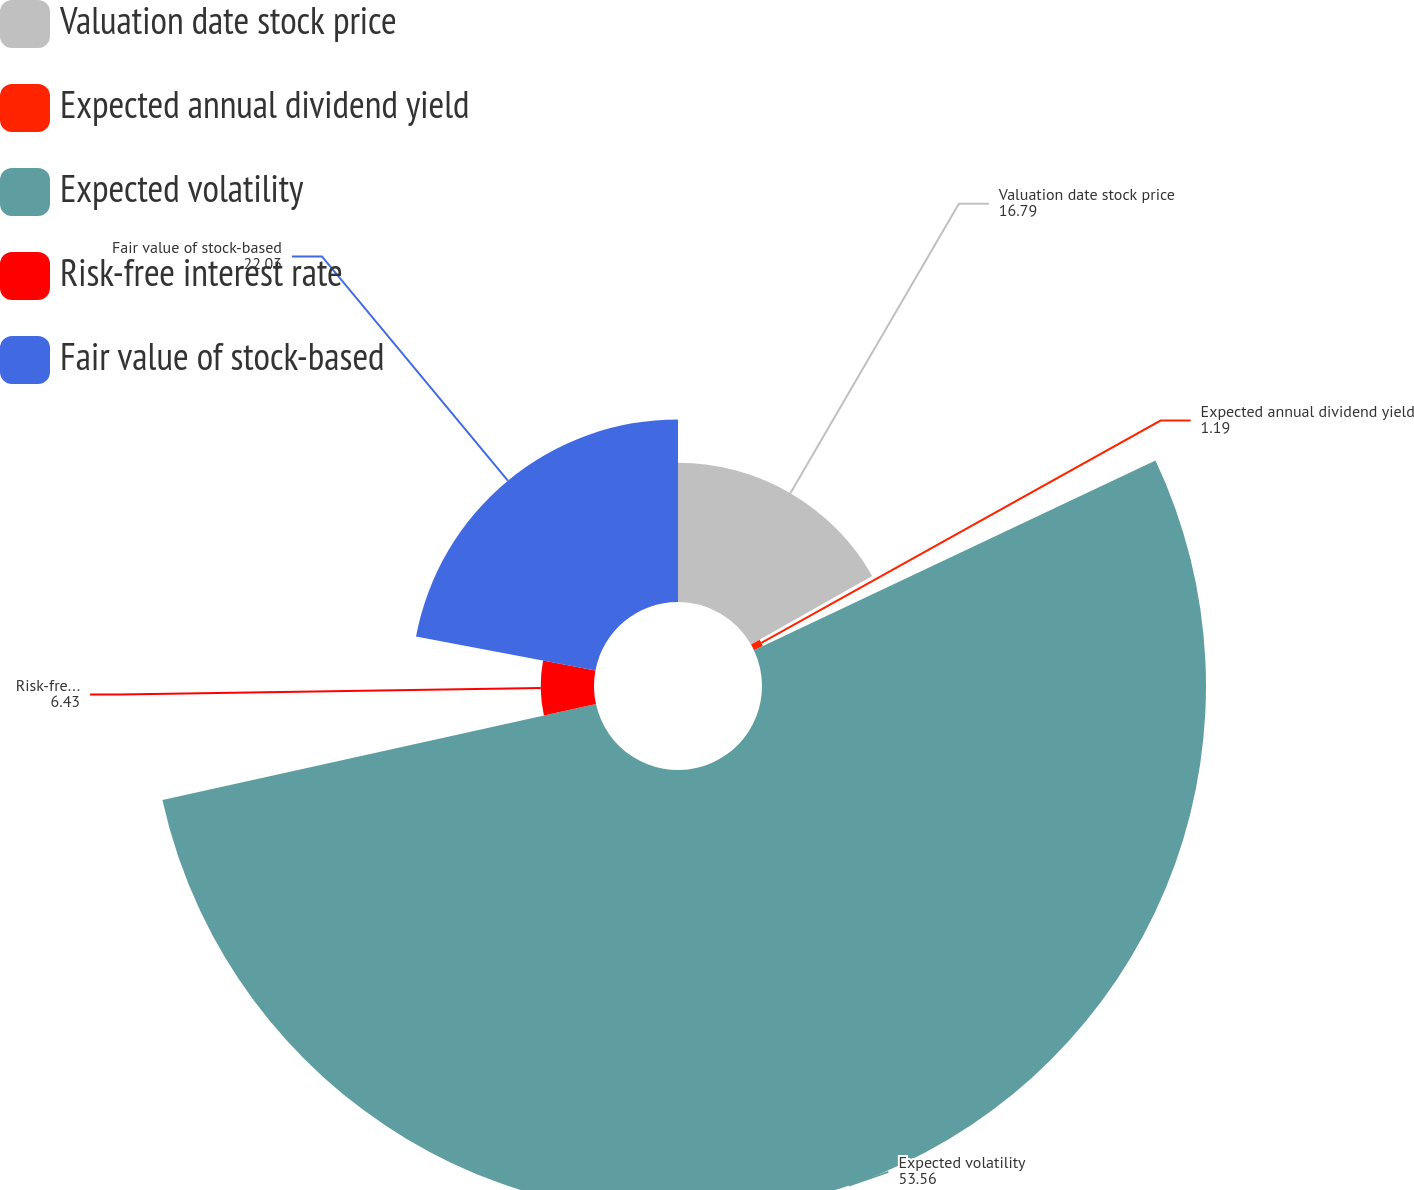Convert chart. <chart><loc_0><loc_0><loc_500><loc_500><pie_chart><fcel>Valuation date stock price<fcel>Expected annual dividend yield<fcel>Expected volatility<fcel>Risk-free interest rate<fcel>Fair value of stock-based<nl><fcel>16.79%<fcel>1.19%<fcel>53.56%<fcel>6.43%<fcel>22.03%<nl></chart> 